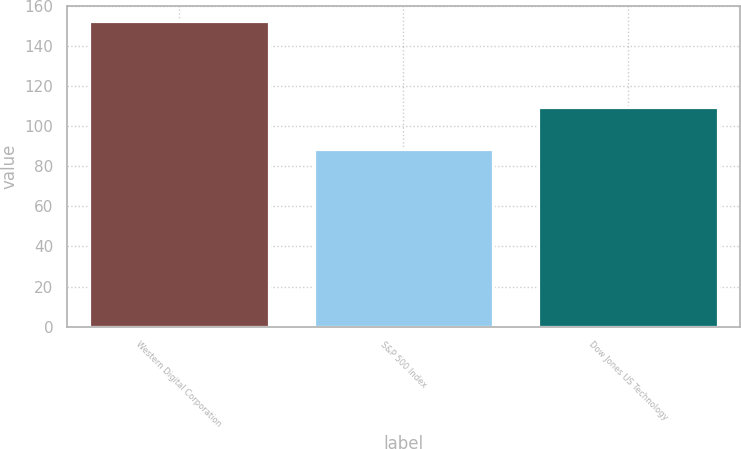<chart> <loc_0><loc_0><loc_500><loc_500><bar_chart><fcel>Western Digital Corporation<fcel>S&P 500 Index<fcel>Dow Jones US Technology<nl><fcel>152.45<fcel>88.46<fcel>109.73<nl></chart> 